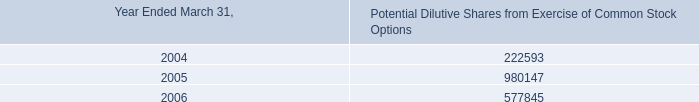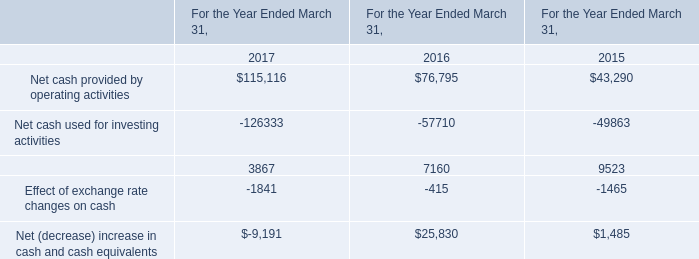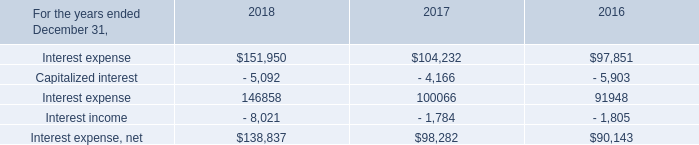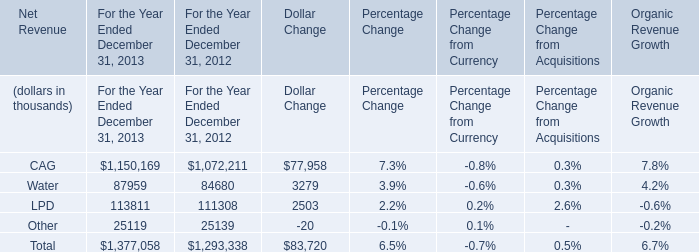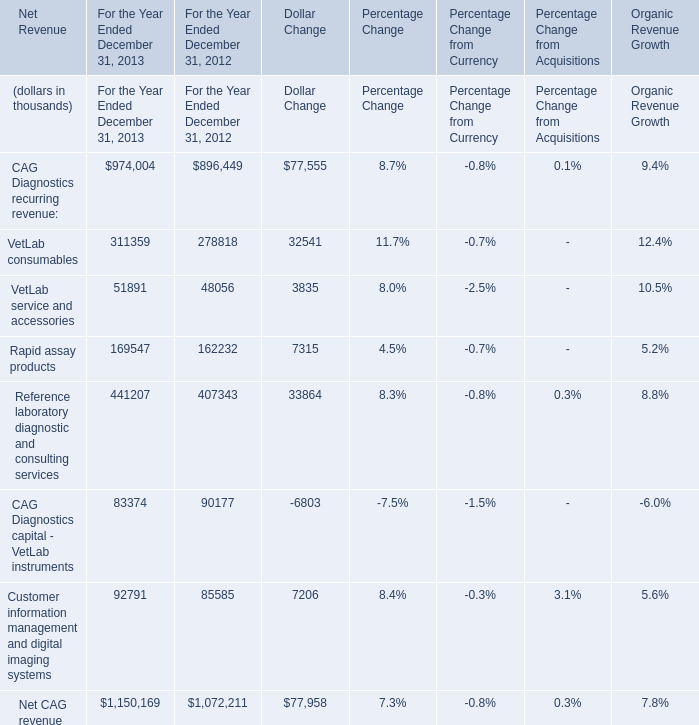What is the sum of the Reference laboratory diagnostic and consulting services in the years where VetLab consumables greater than 0? (in thousand) 
Computations: (441207 + 407343)
Answer: 848550.0. In the year with lowest amount of total Net Revenue, what's the value of Net Revenue of Water? (in thousand) 
Answer: 84680. 